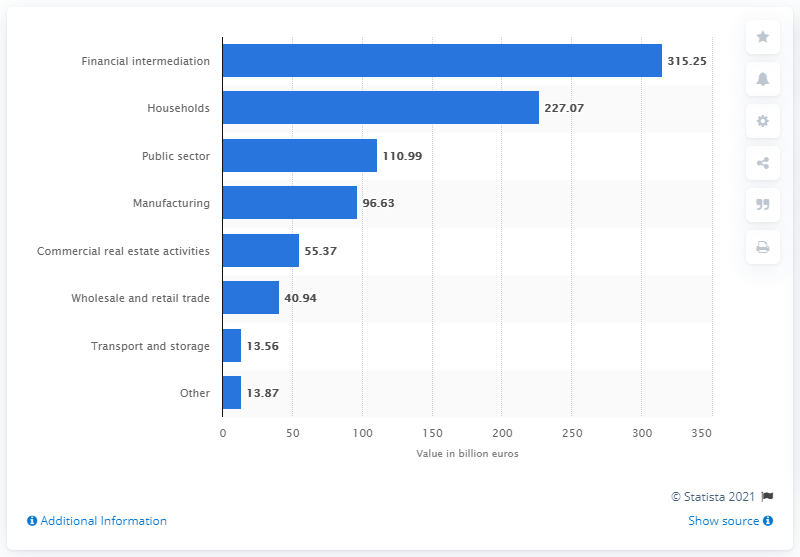Identify some key points in this picture. The value of Deutsche Bank lending to the household sector in 2019 was 227.07. 